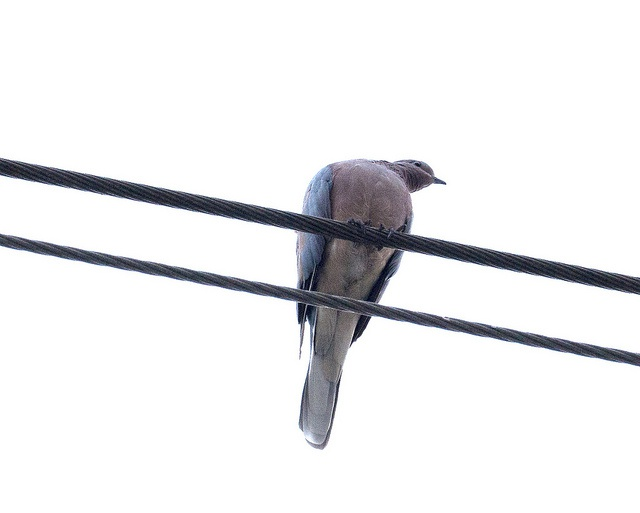Describe the objects in this image and their specific colors. I can see a bird in white, gray, and black tones in this image. 